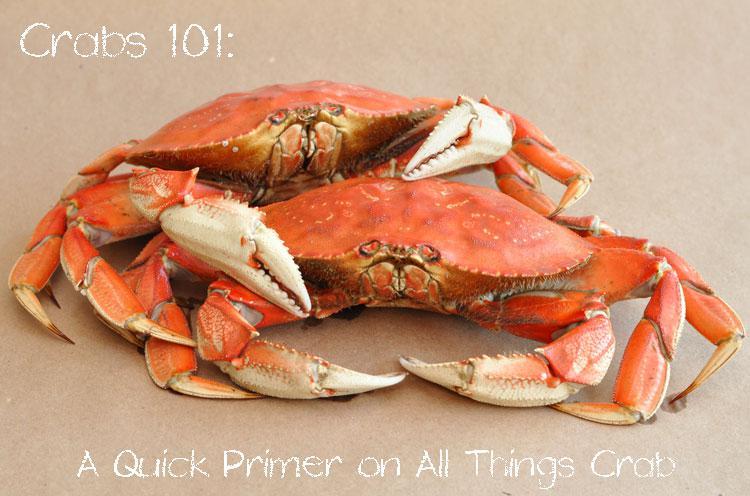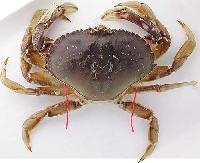The first image is the image on the left, the second image is the image on the right. Examine the images to the left and right. Is the description "The left image contains two crabs." accurate? Answer yes or no. Yes. The first image is the image on the left, the second image is the image on the right. Considering the images on both sides, is "All of the crabs in the images are still whole." valid? Answer yes or no. Yes. 